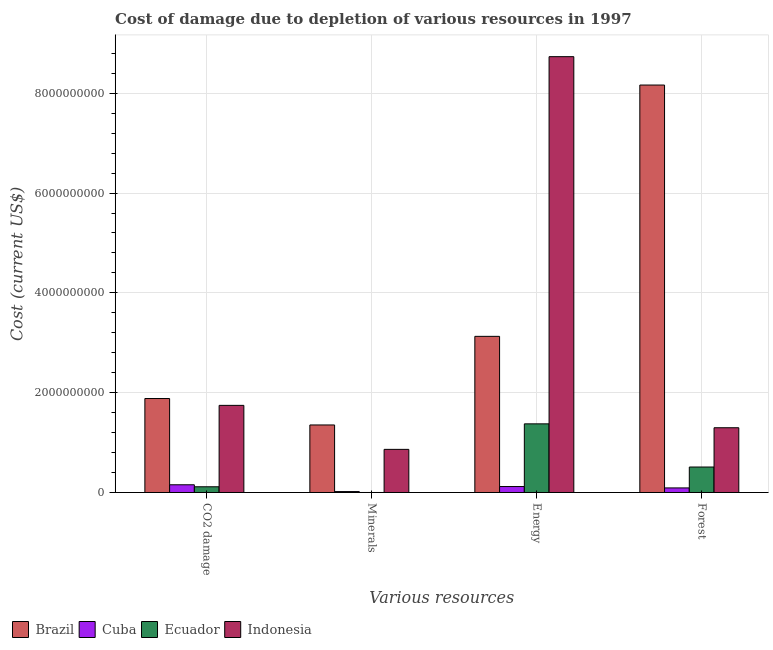How many groups of bars are there?
Your answer should be compact. 4. How many bars are there on the 3rd tick from the left?
Offer a very short reply. 4. How many bars are there on the 1st tick from the right?
Your answer should be very brief. 4. What is the label of the 2nd group of bars from the left?
Your response must be concise. Minerals. What is the cost of damage due to depletion of minerals in Brazil?
Keep it short and to the point. 1.35e+09. Across all countries, what is the maximum cost of damage due to depletion of forests?
Your answer should be compact. 8.16e+09. Across all countries, what is the minimum cost of damage due to depletion of minerals?
Give a very brief answer. 4.30e+04. In which country was the cost of damage due to depletion of coal maximum?
Provide a short and direct response. Brazil. In which country was the cost of damage due to depletion of minerals minimum?
Ensure brevity in your answer.  Ecuador. What is the total cost of damage due to depletion of minerals in the graph?
Your response must be concise. 2.24e+09. What is the difference between the cost of damage due to depletion of coal in Cuba and that in Ecuador?
Give a very brief answer. 3.99e+07. What is the difference between the cost of damage due to depletion of energy in Ecuador and the cost of damage due to depletion of minerals in Indonesia?
Keep it short and to the point. 5.11e+08. What is the average cost of damage due to depletion of forests per country?
Your answer should be compact. 2.52e+09. What is the difference between the cost of damage due to depletion of forests and cost of damage due to depletion of energy in Brazil?
Your response must be concise. 5.04e+09. What is the ratio of the cost of damage due to depletion of forests in Ecuador to that in Brazil?
Make the answer very short. 0.06. Is the cost of damage due to depletion of forests in Ecuador less than that in Indonesia?
Your answer should be compact. Yes. What is the difference between the highest and the second highest cost of damage due to depletion of minerals?
Provide a short and direct response. 4.89e+08. What is the difference between the highest and the lowest cost of damage due to depletion of energy?
Offer a terse response. 8.61e+09. Is it the case that in every country, the sum of the cost of damage due to depletion of energy and cost of damage due to depletion of minerals is greater than the sum of cost of damage due to depletion of coal and cost of damage due to depletion of forests?
Offer a very short reply. No. What does the 1st bar from the left in CO2 damage represents?
Ensure brevity in your answer.  Brazil. Is it the case that in every country, the sum of the cost of damage due to depletion of coal and cost of damage due to depletion of minerals is greater than the cost of damage due to depletion of energy?
Provide a short and direct response. No. How many bars are there?
Ensure brevity in your answer.  16. Are all the bars in the graph horizontal?
Provide a succinct answer. No. How many countries are there in the graph?
Your response must be concise. 4. Where does the legend appear in the graph?
Your answer should be compact. Bottom left. How are the legend labels stacked?
Provide a short and direct response. Horizontal. What is the title of the graph?
Give a very brief answer. Cost of damage due to depletion of various resources in 1997 . What is the label or title of the X-axis?
Your answer should be very brief. Various resources. What is the label or title of the Y-axis?
Make the answer very short. Cost (current US$). What is the Cost (current US$) of Brazil in CO2 damage?
Give a very brief answer. 1.88e+09. What is the Cost (current US$) in Cuba in CO2 damage?
Provide a short and direct response. 1.54e+08. What is the Cost (current US$) of Ecuador in CO2 damage?
Offer a terse response. 1.15e+08. What is the Cost (current US$) in Indonesia in CO2 damage?
Ensure brevity in your answer.  1.75e+09. What is the Cost (current US$) of Brazil in Minerals?
Ensure brevity in your answer.  1.35e+09. What is the Cost (current US$) in Cuba in Minerals?
Keep it short and to the point. 1.82e+07. What is the Cost (current US$) of Ecuador in Minerals?
Your response must be concise. 4.30e+04. What is the Cost (current US$) of Indonesia in Minerals?
Your answer should be very brief. 8.64e+08. What is the Cost (current US$) of Brazil in Energy?
Offer a terse response. 3.13e+09. What is the Cost (current US$) of Cuba in Energy?
Give a very brief answer. 1.19e+08. What is the Cost (current US$) of Ecuador in Energy?
Make the answer very short. 1.38e+09. What is the Cost (current US$) in Indonesia in Energy?
Make the answer very short. 8.73e+09. What is the Cost (current US$) in Brazil in Forest?
Your answer should be very brief. 8.16e+09. What is the Cost (current US$) of Cuba in Forest?
Ensure brevity in your answer.  9.15e+07. What is the Cost (current US$) in Ecuador in Forest?
Keep it short and to the point. 5.10e+08. What is the Cost (current US$) in Indonesia in Forest?
Offer a terse response. 1.30e+09. Across all Various resources, what is the maximum Cost (current US$) in Brazil?
Offer a very short reply. 8.16e+09. Across all Various resources, what is the maximum Cost (current US$) in Cuba?
Your answer should be compact. 1.54e+08. Across all Various resources, what is the maximum Cost (current US$) of Ecuador?
Provide a succinct answer. 1.38e+09. Across all Various resources, what is the maximum Cost (current US$) of Indonesia?
Give a very brief answer. 8.73e+09. Across all Various resources, what is the minimum Cost (current US$) in Brazil?
Keep it short and to the point. 1.35e+09. Across all Various resources, what is the minimum Cost (current US$) of Cuba?
Make the answer very short. 1.82e+07. Across all Various resources, what is the minimum Cost (current US$) of Ecuador?
Provide a short and direct response. 4.30e+04. Across all Various resources, what is the minimum Cost (current US$) of Indonesia?
Offer a very short reply. 8.64e+08. What is the total Cost (current US$) of Brazil in the graph?
Your response must be concise. 1.45e+1. What is the total Cost (current US$) in Cuba in the graph?
Your response must be concise. 3.83e+08. What is the total Cost (current US$) of Ecuador in the graph?
Provide a short and direct response. 2.00e+09. What is the total Cost (current US$) of Indonesia in the graph?
Your answer should be compact. 1.26e+1. What is the difference between the Cost (current US$) of Brazil in CO2 damage and that in Minerals?
Your response must be concise. 5.30e+08. What is the difference between the Cost (current US$) in Cuba in CO2 damage and that in Minerals?
Keep it short and to the point. 1.36e+08. What is the difference between the Cost (current US$) of Ecuador in CO2 damage and that in Minerals?
Offer a terse response. 1.14e+08. What is the difference between the Cost (current US$) in Indonesia in CO2 damage and that in Minerals?
Your answer should be compact. 8.82e+08. What is the difference between the Cost (current US$) of Brazil in CO2 damage and that in Energy?
Your answer should be very brief. -1.25e+09. What is the difference between the Cost (current US$) in Cuba in CO2 damage and that in Energy?
Provide a short and direct response. 3.54e+07. What is the difference between the Cost (current US$) in Ecuador in CO2 damage and that in Energy?
Your answer should be compact. -1.26e+09. What is the difference between the Cost (current US$) in Indonesia in CO2 damage and that in Energy?
Provide a short and direct response. -6.99e+09. What is the difference between the Cost (current US$) in Brazil in CO2 damage and that in Forest?
Keep it short and to the point. -6.28e+09. What is the difference between the Cost (current US$) in Cuba in CO2 damage and that in Forest?
Provide a succinct answer. 6.29e+07. What is the difference between the Cost (current US$) of Ecuador in CO2 damage and that in Forest?
Provide a succinct answer. -3.96e+08. What is the difference between the Cost (current US$) of Indonesia in CO2 damage and that in Forest?
Offer a terse response. 4.49e+08. What is the difference between the Cost (current US$) of Brazil in Minerals and that in Energy?
Ensure brevity in your answer.  -1.78e+09. What is the difference between the Cost (current US$) in Cuba in Minerals and that in Energy?
Offer a very short reply. -1.01e+08. What is the difference between the Cost (current US$) in Ecuador in Minerals and that in Energy?
Offer a terse response. -1.38e+09. What is the difference between the Cost (current US$) of Indonesia in Minerals and that in Energy?
Your answer should be very brief. -7.87e+09. What is the difference between the Cost (current US$) in Brazil in Minerals and that in Forest?
Your answer should be compact. -6.81e+09. What is the difference between the Cost (current US$) in Cuba in Minerals and that in Forest?
Your response must be concise. -7.32e+07. What is the difference between the Cost (current US$) in Ecuador in Minerals and that in Forest?
Provide a succinct answer. -5.10e+08. What is the difference between the Cost (current US$) in Indonesia in Minerals and that in Forest?
Provide a short and direct response. -4.33e+08. What is the difference between the Cost (current US$) of Brazil in Energy and that in Forest?
Ensure brevity in your answer.  -5.04e+09. What is the difference between the Cost (current US$) of Cuba in Energy and that in Forest?
Your response must be concise. 2.76e+07. What is the difference between the Cost (current US$) in Ecuador in Energy and that in Forest?
Offer a very short reply. 8.65e+08. What is the difference between the Cost (current US$) of Indonesia in Energy and that in Forest?
Your answer should be compact. 7.44e+09. What is the difference between the Cost (current US$) in Brazil in CO2 damage and the Cost (current US$) in Cuba in Minerals?
Your response must be concise. 1.86e+09. What is the difference between the Cost (current US$) in Brazil in CO2 damage and the Cost (current US$) in Ecuador in Minerals?
Offer a very short reply. 1.88e+09. What is the difference between the Cost (current US$) of Brazil in CO2 damage and the Cost (current US$) of Indonesia in Minerals?
Provide a succinct answer. 1.02e+09. What is the difference between the Cost (current US$) in Cuba in CO2 damage and the Cost (current US$) in Ecuador in Minerals?
Make the answer very short. 1.54e+08. What is the difference between the Cost (current US$) in Cuba in CO2 damage and the Cost (current US$) in Indonesia in Minerals?
Your response must be concise. -7.09e+08. What is the difference between the Cost (current US$) of Ecuador in CO2 damage and the Cost (current US$) of Indonesia in Minerals?
Give a very brief answer. -7.49e+08. What is the difference between the Cost (current US$) of Brazil in CO2 damage and the Cost (current US$) of Cuba in Energy?
Offer a terse response. 1.76e+09. What is the difference between the Cost (current US$) in Brazil in CO2 damage and the Cost (current US$) in Ecuador in Energy?
Provide a short and direct response. 5.08e+08. What is the difference between the Cost (current US$) of Brazil in CO2 damage and the Cost (current US$) of Indonesia in Energy?
Your answer should be very brief. -6.85e+09. What is the difference between the Cost (current US$) of Cuba in CO2 damage and the Cost (current US$) of Ecuador in Energy?
Your answer should be compact. -1.22e+09. What is the difference between the Cost (current US$) in Cuba in CO2 damage and the Cost (current US$) in Indonesia in Energy?
Offer a terse response. -8.58e+09. What is the difference between the Cost (current US$) of Ecuador in CO2 damage and the Cost (current US$) of Indonesia in Energy?
Ensure brevity in your answer.  -8.62e+09. What is the difference between the Cost (current US$) of Brazil in CO2 damage and the Cost (current US$) of Cuba in Forest?
Your answer should be very brief. 1.79e+09. What is the difference between the Cost (current US$) in Brazil in CO2 damage and the Cost (current US$) in Ecuador in Forest?
Your answer should be compact. 1.37e+09. What is the difference between the Cost (current US$) in Brazil in CO2 damage and the Cost (current US$) in Indonesia in Forest?
Provide a succinct answer. 5.86e+08. What is the difference between the Cost (current US$) of Cuba in CO2 damage and the Cost (current US$) of Ecuador in Forest?
Provide a short and direct response. -3.56e+08. What is the difference between the Cost (current US$) in Cuba in CO2 damage and the Cost (current US$) in Indonesia in Forest?
Provide a succinct answer. -1.14e+09. What is the difference between the Cost (current US$) of Ecuador in CO2 damage and the Cost (current US$) of Indonesia in Forest?
Provide a short and direct response. -1.18e+09. What is the difference between the Cost (current US$) in Brazil in Minerals and the Cost (current US$) in Cuba in Energy?
Keep it short and to the point. 1.23e+09. What is the difference between the Cost (current US$) of Brazil in Minerals and the Cost (current US$) of Ecuador in Energy?
Your response must be concise. -2.22e+07. What is the difference between the Cost (current US$) of Brazil in Minerals and the Cost (current US$) of Indonesia in Energy?
Give a very brief answer. -7.38e+09. What is the difference between the Cost (current US$) in Cuba in Minerals and the Cost (current US$) in Ecuador in Energy?
Your answer should be compact. -1.36e+09. What is the difference between the Cost (current US$) of Cuba in Minerals and the Cost (current US$) of Indonesia in Energy?
Your answer should be very brief. -8.71e+09. What is the difference between the Cost (current US$) in Ecuador in Minerals and the Cost (current US$) in Indonesia in Energy?
Make the answer very short. -8.73e+09. What is the difference between the Cost (current US$) of Brazil in Minerals and the Cost (current US$) of Cuba in Forest?
Provide a succinct answer. 1.26e+09. What is the difference between the Cost (current US$) of Brazil in Minerals and the Cost (current US$) of Ecuador in Forest?
Ensure brevity in your answer.  8.43e+08. What is the difference between the Cost (current US$) of Brazil in Minerals and the Cost (current US$) of Indonesia in Forest?
Your response must be concise. 5.58e+07. What is the difference between the Cost (current US$) in Cuba in Minerals and the Cost (current US$) in Ecuador in Forest?
Make the answer very short. -4.92e+08. What is the difference between the Cost (current US$) of Cuba in Minerals and the Cost (current US$) of Indonesia in Forest?
Ensure brevity in your answer.  -1.28e+09. What is the difference between the Cost (current US$) of Ecuador in Minerals and the Cost (current US$) of Indonesia in Forest?
Make the answer very short. -1.30e+09. What is the difference between the Cost (current US$) of Brazil in Energy and the Cost (current US$) of Cuba in Forest?
Ensure brevity in your answer.  3.04e+09. What is the difference between the Cost (current US$) of Brazil in Energy and the Cost (current US$) of Ecuador in Forest?
Provide a short and direct response. 2.62e+09. What is the difference between the Cost (current US$) in Brazil in Energy and the Cost (current US$) in Indonesia in Forest?
Provide a short and direct response. 1.83e+09. What is the difference between the Cost (current US$) in Cuba in Energy and the Cost (current US$) in Ecuador in Forest?
Make the answer very short. -3.91e+08. What is the difference between the Cost (current US$) of Cuba in Energy and the Cost (current US$) of Indonesia in Forest?
Provide a succinct answer. -1.18e+09. What is the difference between the Cost (current US$) of Ecuador in Energy and the Cost (current US$) of Indonesia in Forest?
Provide a succinct answer. 7.80e+07. What is the average Cost (current US$) in Brazil per Various resources?
Your answer should be very brief. 3.63e+09. What is the average Cost (current US$) in Cuba per Various resources?
Your response must be concise. 9.58e+07. What is the average Cost (current US$) of Ecuador per Various resources?
Provide a succinct answer. 5.00e+08. What is the average Cost (current US$) of Indonesia per Various resources?
Ensure brevity in your answer.  3.16e+09. What is the difference between the Cost (current US$) of Brazil and Cost (current US$) of Cuba in CO2 damage?
Keep it short and to the point. 1.73e+09. What is the difference between the Cost (current US$) in Brazil and Cost (current US$) in Ecuador in CO2 damage?
Keep it short and to the point. 1.77e+09. What is the difference between the Cost (current US$) in Brazil and Cost (current US$) in Indonesia in CO2 damage?
Give a very brief answer. 1.37e+08. What is the difference between the Cost (current US$) of Cuba and Cost (current US$) of Ecuador in CO2 damage?
Keep it short and to the point. 3.99e+07. What is the difference between the Cost (current US$) of Cuba and Cost (current US$) of Indonesia in CO2 damage?
Provide a short and direct response. -1.59e+09. What is the difference between the Cost (current US$) of Ecuador and Cost (current US$) of Indonesia in CO2 damage?
Give a very brief answer. -1.63e+09. What is the difference between the Cost (current US$) of Brazil and Cost (current US$) of Cuba in Minerals?
Ensure brevity in your answer.  1.33e+09. What is the difference between the Cost (current US$) in Brazil and Cost (current US$) in Ecuador in Minerals?
Ensure brevity in your answer.  1.35e+09. What is the difference between the Cost (current US$) in Brazil and Cost (current US$) in Indonesia in Minerals?
Ensure brevity in your answer.  4.89e+08. What is the difference between the Cost (current US$) in Cuba and Cost (current US$) in Ecuador in Minerals?
Give a very brief answer. 1.82e+07. What is the difference between the Cost (current US$) of Cuba and Cost (current US$) of Indonesia in Minerals?
Give a very brief answer. -8.46e+08. What is the difference between the Cost (current US$) of Ecuador and Cost (current US$) of Indonesia in Minerals?
Ensure brevity in your answer.  -8.64e+08. What is the difference between the Cost (current US$) of Brazil and Cost (current US$) of Cuba in Energy?
Give a very brief answer. 3.01e+09. What is the difference between the Cost (current US$) of Brazil and Cost (current US$) of Ecuador in Energy?
Provide a short and direct response. 1.75e+09. What is the difference between the Cost (current US$) of Brazil and Cost (current US$) of Indonesia in Energy?
Offer a very short reply. -5.60e+09. What is the difference between the Cost (current US$) of Cuba and Cost (current US$) of Ecuador in Energy?
Give a very brief answer. -1.26e+09. What is the difference between the Cost (current US$) of Cuba and Cost (current US$) of Indonesia in Energy?
Make the answer very short. -8.61e+09. What is the difference between the Cost (current US$) of Ecuador and Cost (current US$) of Indonesia in Energy?
Make the answer very short. -7.36e+09. What is the difference between the Cost (current US$) in Brazil and Cost (current US$) in Cuba in Forest?
Your answer should be very brief. 8.07e+09. What is the difference between the Cost (current US$) of Brazil and Cost (current US$) of Ecuador in Forest?
Give a very brief answer. 7.65e+09. What is the difference between the Cost (current US$) in Brazil and Cost (current US$) in Indonesia in Forest?
Offer a very short reply. 6.87e+09. What is the difference between the Cost (current US$) in Cuba and Cost (current US$) in Ecuador in Forest?
Ensure brevity in your answer.  -4.19e+08. What is the difference between the Cost (current US$) in Cuba and Cost (current US$) in Indonesia in Forest?
Make the answer very short. -1.21e+09. What is the difference between the Cost (current US$) in Ecuador and Cost (current US$) in Indonesia in Forest?
Provide a succinct answer. -7.87e+08. What is the ratio of the Cost (current US$) in Brazil in CO2 damage to that in Minerals?
Ensure brevity in your answer.  1.39. What is the ratio of the Cost (current US$) in Cuba in CO2 damage to that in Minerals?
Offer a terse response. 8.47. What is the ratio of the Cost (current US$) in Ecuador in CO2 damage to that in Minerals?
Your response must be concise. 2659.94. What is the ratio of the Cost (current US$) in Indonesia in CO2 damage to that in Minerals?
Your response must be concise. 2.02. What is the ratio of the Cost (current US$) of Brazil in CO2 damage to that in Energy?
Provide a succinct answer. 0.6. What is the ratio of the Cost (current US$) in Cuba in CO2 damage to that in Energy?
Your answer should be compact. 1.3. What is the ratio of the Cost (current US$) of Ecuador in CO2 damage to that in Energy?
Your response must be concise. 0.08. What is the ratio of the Cost (current US$) in Indonesia in CO2 damage to that in Energy?
Provide a succinct answer. 0.2. What is the ratio of the Cost (current US$) of Brazil in CO2 damage to that in Forest?
Offer a terse response. 0.23. What is the ratio of the Cost (current US$) in Cuba in CO2 damage to that in Forest?
Provide a short and direct response. 1.69. What is the ratio of the Cost (current US$) of Ecuador in CO2 damage to that in Forest?
Your answer should be very brief. 0.22. What is the ratio of the Cost (current US$) of Indonesia in CO2 damage to that in Forest?
Your response must be concise. 1.35. What is the ratio of the Cost (current US$) in Brazil in Minerals to that in Energy?
Offer a terse response. 0.43. What is the ratio of the Cost (current US$) in Cuba in Minerals to that in Energy?
Your answer should be very brief. 0.15. What is the ratio of the Cost (current US$) of Indonesia in Minerals to that in Energy?
Offer a very short reply. 0.1. What is the ratio of the Cost (current US$) of Brazil in Minerals to that in Forest?
Offer a very short reply. 0.17. What is the ratio of the Cost (current US$) in Cuba in Minerals to that in Forest?
Offer a terse response. 0.2. What is the ratio of the Cost (current US$) of Indonesia in Minerals to that in Forest?
Make the answer very short. 0.67. What is the ratio of the Cost (current US$) of Brazil in Energy to that in Forest?
Your response must be concise. 0.38. What is the ratio of the Cost (current US$) in Cuba in Energy to that in Forest?
Keep it short and to the point. 1.3. What is the ratio of the Cost (current US$) of Ecuador in Energy to that in Forest?
Give a very brief answer. 2.7. What is the ratio of the Cost (current US$) in Indonesia in Energy to that in Forest?
Provide a succinct answer. 6.73. What is the difference between the highest and the second highest Cost (current US$) in Brazil?
Provide a short and direct response. 5.04e+09. What is the difference between the highest and the second highest Cost (current US$) of Cuba?
Make the answer very short. 3.54e+07. What is the difference between the highest and the second highest Cost (current US$) in Ecuador?
Give a very brief answer. 8.65e+08. What is the difference between the highest and the second highest Cost (current US$) in Indonesia?
Your answer should be compact. 6.99e+09. What is the difference between the highest and the lowest Cost (current US$) in Brazil?
Offer a terse response. 6.81e+09. What is the difference between the highest and the lowest Cost (current US$) in Cuba?
Ensure brevity in your answer.  1.36e+08. What is the difference between the highest and the lowest Cost (current US$) in Ecuador?
Your answer should be very brief. 1.38e+09. What is the difference between the highest and the lowest Cost (current US$) of Indonesia?
Make the answer very short. 7.87e+09. 